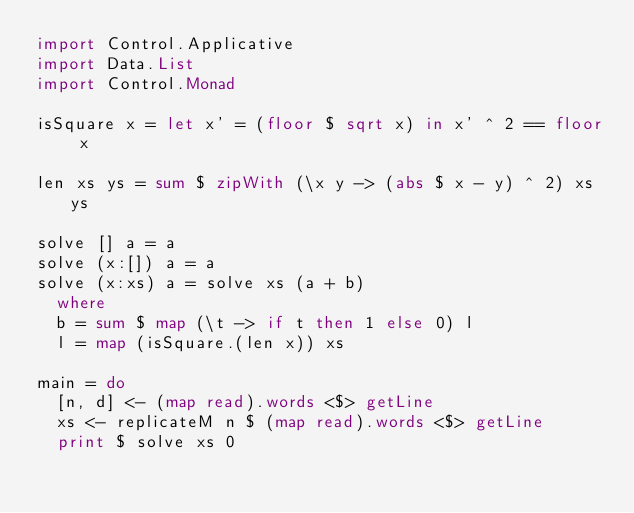<code> <loc_0><loc_0><loc_500><loc_500><_Haskell_>import Control.Applicative
import Data.List
import Control.Monad

isSquare x = let x' = (floor $ sqrt x) in x' ^ 2 == floor x

len xs ys = sum $ zipWith (\x y -> (abs $ x - y) ^ 2) xs ys

solve [] a = a
solve (x:[]) a = a
solve (x:xs) a = solve xs (a + b)
  where
  b = sum $ map (\t -> if t then 1 else 0) l
  l = map (isSquare.(len x)) xs

main = do
  [n, d] <- (map read).words <$> getLine
  xs <- replicateM n $ (map read).words <$> getLine
  print $ solve xs 0
</code> 